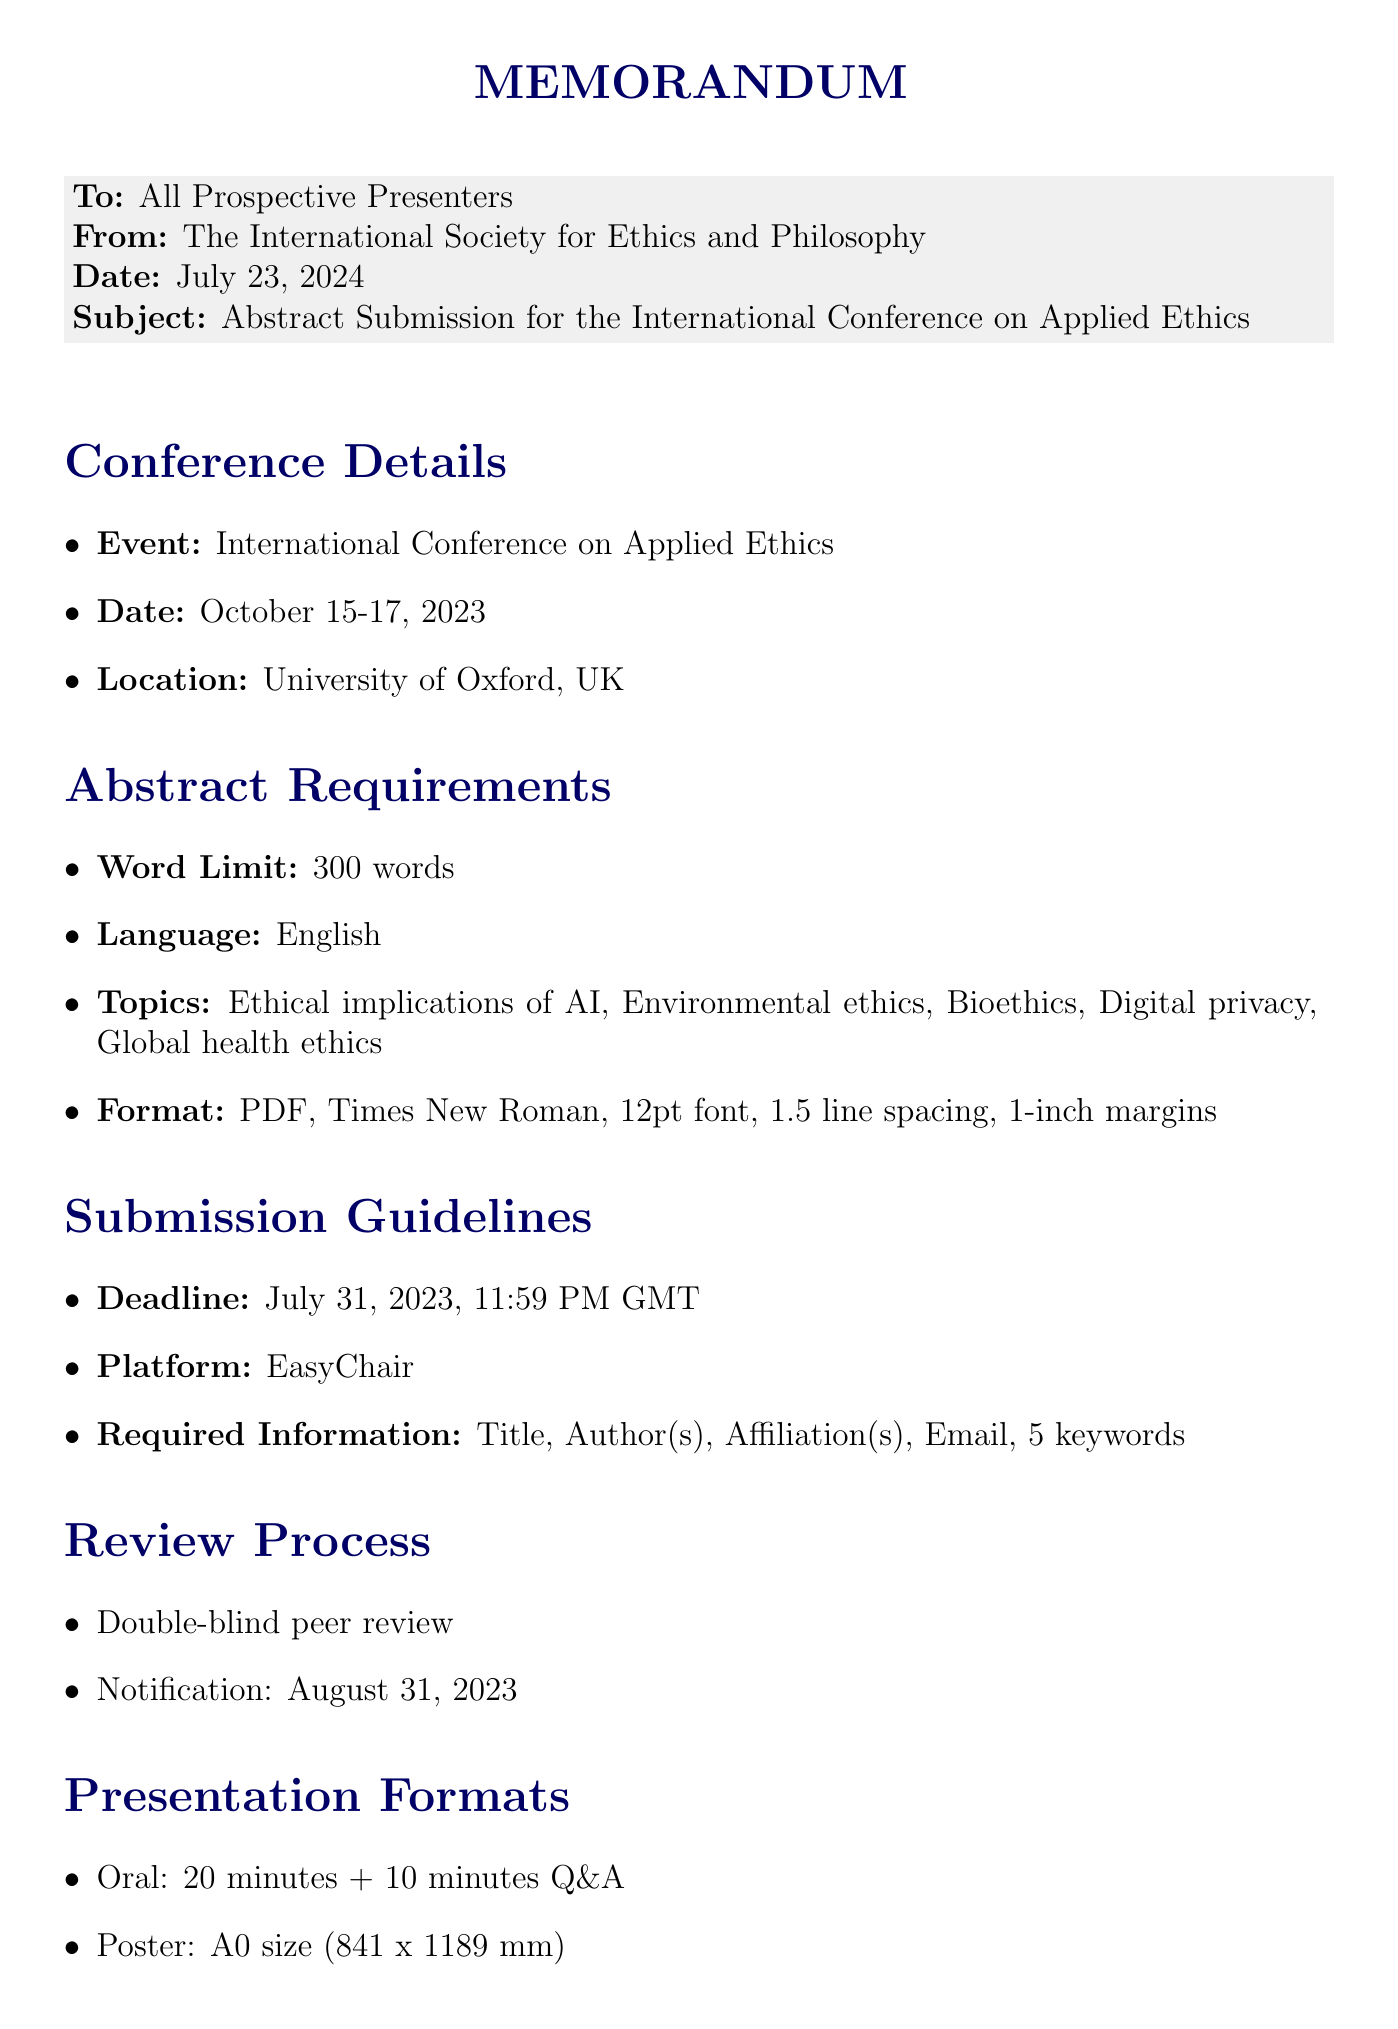What is the conference name? The name of the conference is provided in the conference details section of the document.
Answer: International Conference on Applied Ethics What is the submission deadline? The deadline for abstract submission is specified in the submission guidelines section.
Answer: July 31, 2023, 11:59 PM GMT What is the maximum word limit for the abstract? The word limit is stated in the abstract requirements section of the document.
Answer: 300 words What is the language requirement for the abstract? The required language for the abstract is mentioned in the abstract requirements section.
Answer: English What review process will be used? The type of review process is outlined in the review process section of the document.
Answer: Double-blind peer review When will notification of acceptance be given? The notification date for acceptance is specified in the review process section.
Answer: August 31, 2023 What is one of the presentation formats available? The document lists various presentation formats in the presentation formats section.
Answer: Oral presentation What is the discount for full-time graduate students? The specific discount for graduate students is mentioned in the graduate student opportunities section.
Answer: 50% discount Where should abstracts be submitted? The submission platform is provided in the submission guidelines section of the document.
Answer: EasyChair 